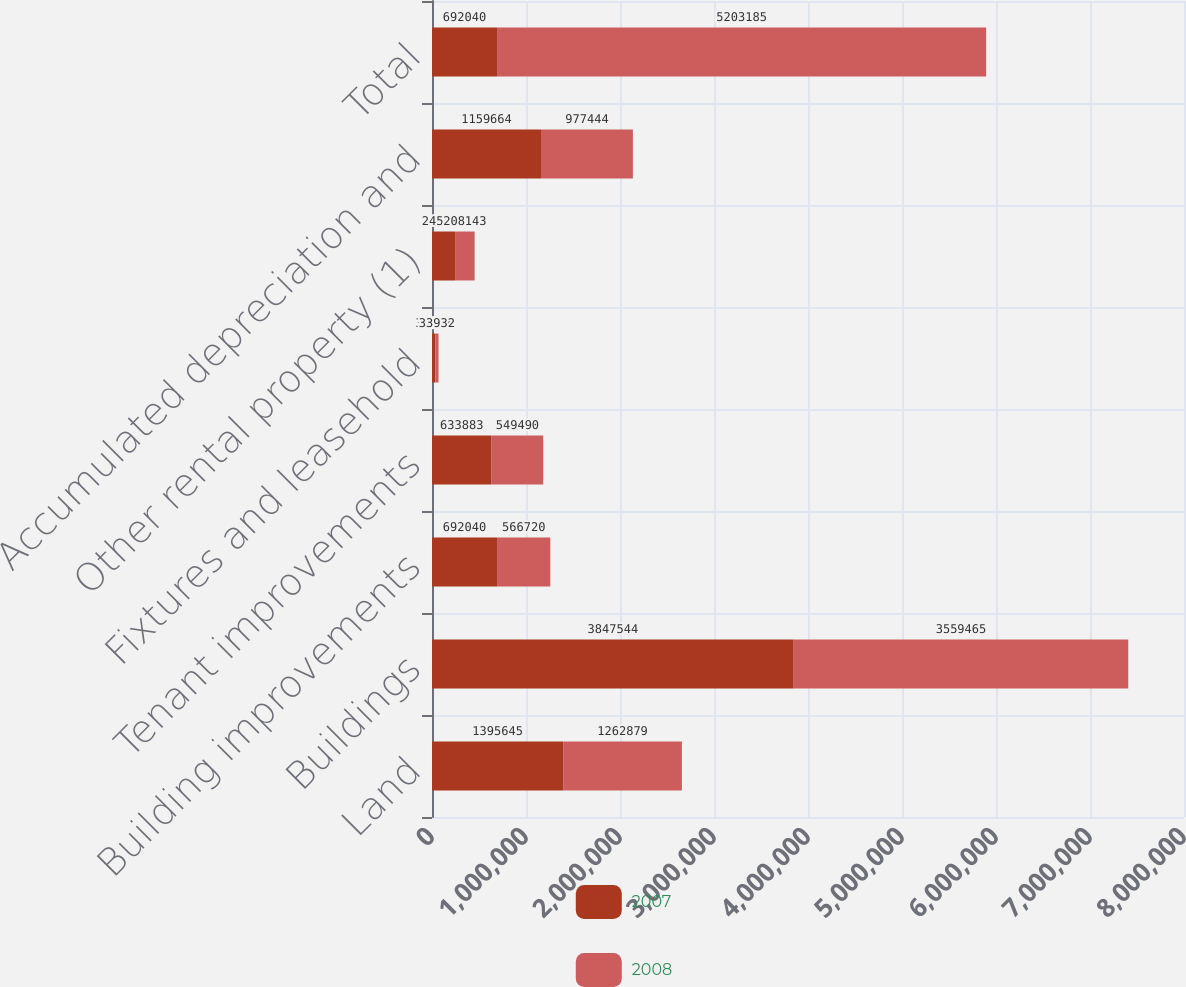Convert chart. <chart><loc_0><loc_0><loc_500><loc_500><stacked_bar_chart><ecel><fcel>Land<fcel>Buildings<fcel>Building improvements<fcel>Tenant improvements<fcel>Fixtures and leasehold<fcel>Other rental property (1)<fcel>Accumulated depreciation and<fcel>Total<nl><fcel>2007<fcel>1.39564e+06<fcel>3.84754e+06<fcel>692040<fcel>633883<fcel>35377<fcel>245452<fcel>1.15966e+06<fcel>692040<nl><fcel>2008<fcel>1.26288e+06<fcel>3.55946e+06<fcel>566720<fcel>549490<fcel>33932<fcel>208143<fcel>977444<fcel>5.20318e+06<nl></chart> 